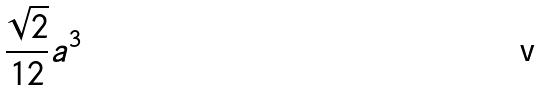<formula> <loc_0><loc_0><loc_500><loc_500>\frac { \sqrt { 2 } } { 1 2 } a ^ { 3 }</formula> 